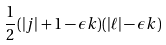Convert formula to latex. <formula><loc_0><loc_0><loc_500><loc_500>\frac { 1 } { 2 } ( | j | + 1 - \epsilon k ) ( | \ell | - \epsilon k )</formula> 